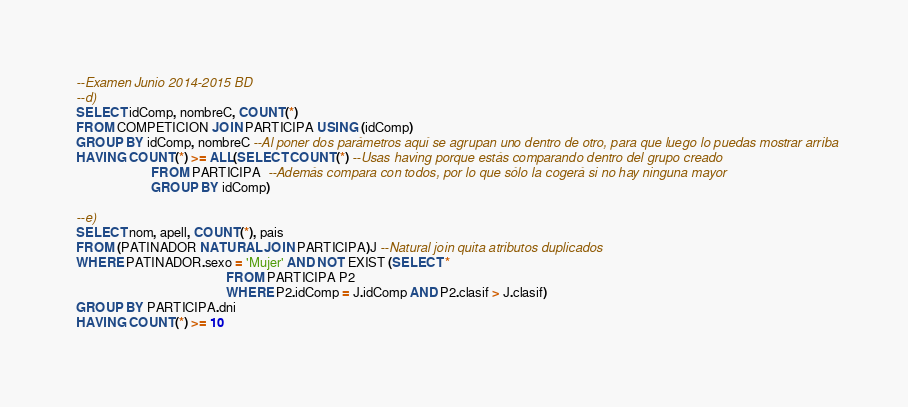<code> <loc_0><loc_0><loc_500><loc_500><_SQL_>--Examen Junio 2014-2015 BD
--d)
SELECT idComp, nombreC, COUNT(*)
FROM COMPETICION JOIN PARTICIPA USING (idComp)
GROUP BY idComp, nombreC --Al poner dos parámetros aquí se agrupan uno dentro de otro, para que luego lo puedas mostrar arriba
HAVING COUNT(*) >= ALL(SELECT COUNT(*) --Usas having porque estás comparando dentro del grupo creado
                       FROM PARTICIPA  --Además compara con todos, por lo que sólo la cogerá si no hay ninguna mayor
                       GROUP BY idComp)
                       
--e)
SELECT nom, apell, COUNT(*), pais 
FROM (PATINADOR NATURAL JOIN PARTICIPA)J --Natural join quita atributos duplicados
WHERE PATINADOR.sexo = 'Mujer' AND NOT EXIST (SELECT *
                                              FROM PARTICIPA P2
                                              WHERE P2.idComp = J.idComp AND P2.clasif > J.clasif)
GROUP BY PARTICIPA.dni
HAVING COUNT(*) >= 10</code> 